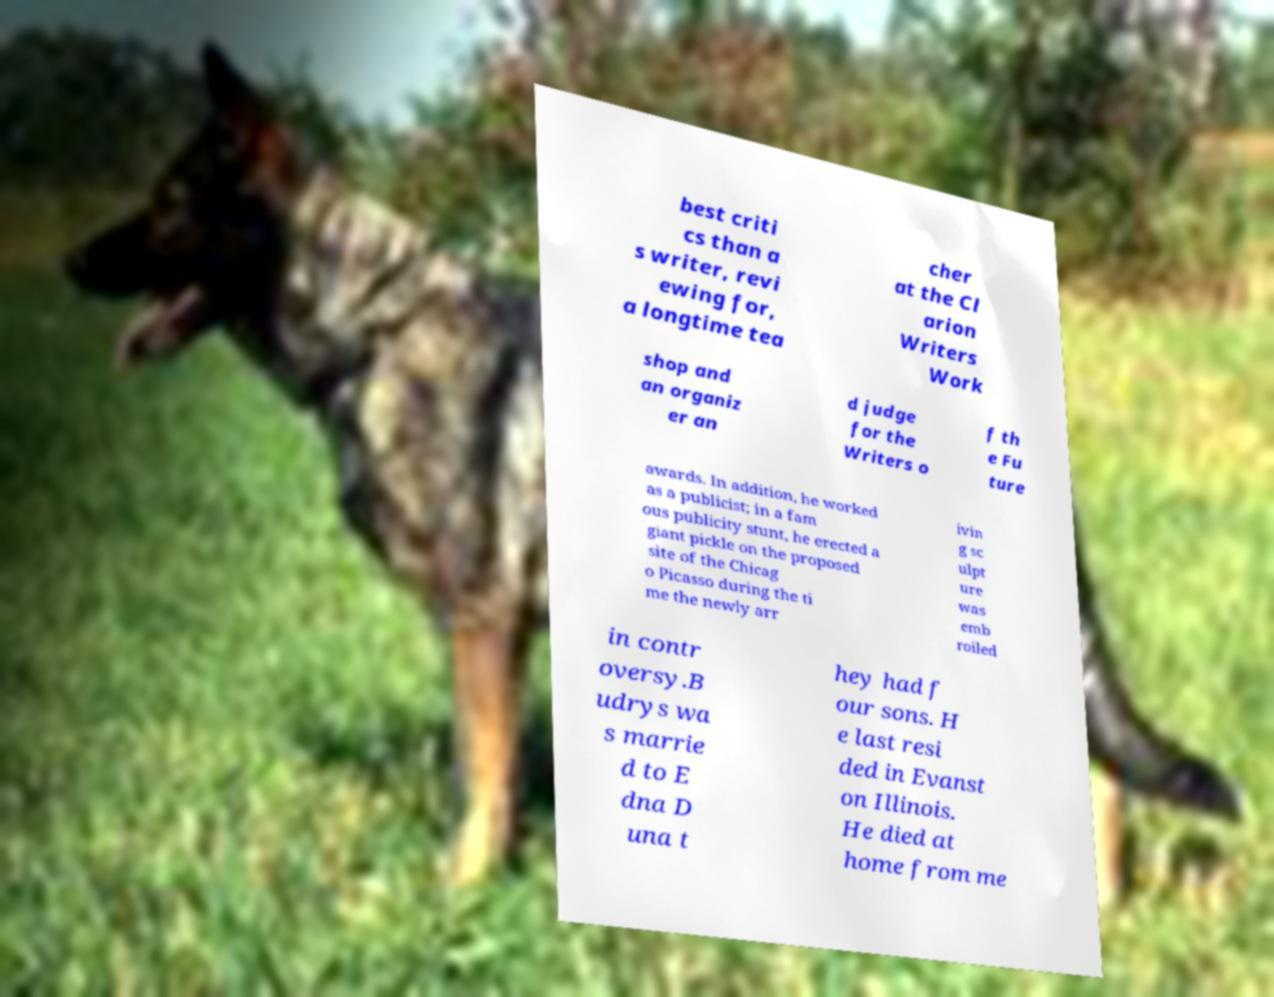Can you read and provide the text displayed in the image?This photo seems to have some interesting text. Can you extract and type it out for me? best criti cs than a s writer, revi ewing for, a longtime tea cher at the Cl arion Writers Work shop and an organiz er an d judge for the Writers o f th e Fu ture awards. In addition, he worked as a publicist; in a fam ous publicity stunt, he erected a giant pickle on the proposed site of the Chicag o Picasso during the ti me the newly arr ivin g sc ulpt ure was emb roiled in contr oversy.B udrys wa s marrie d to E dna D una t hey had f our sons. H e last resi ded in Evanst on Illinois. He died at home from me 